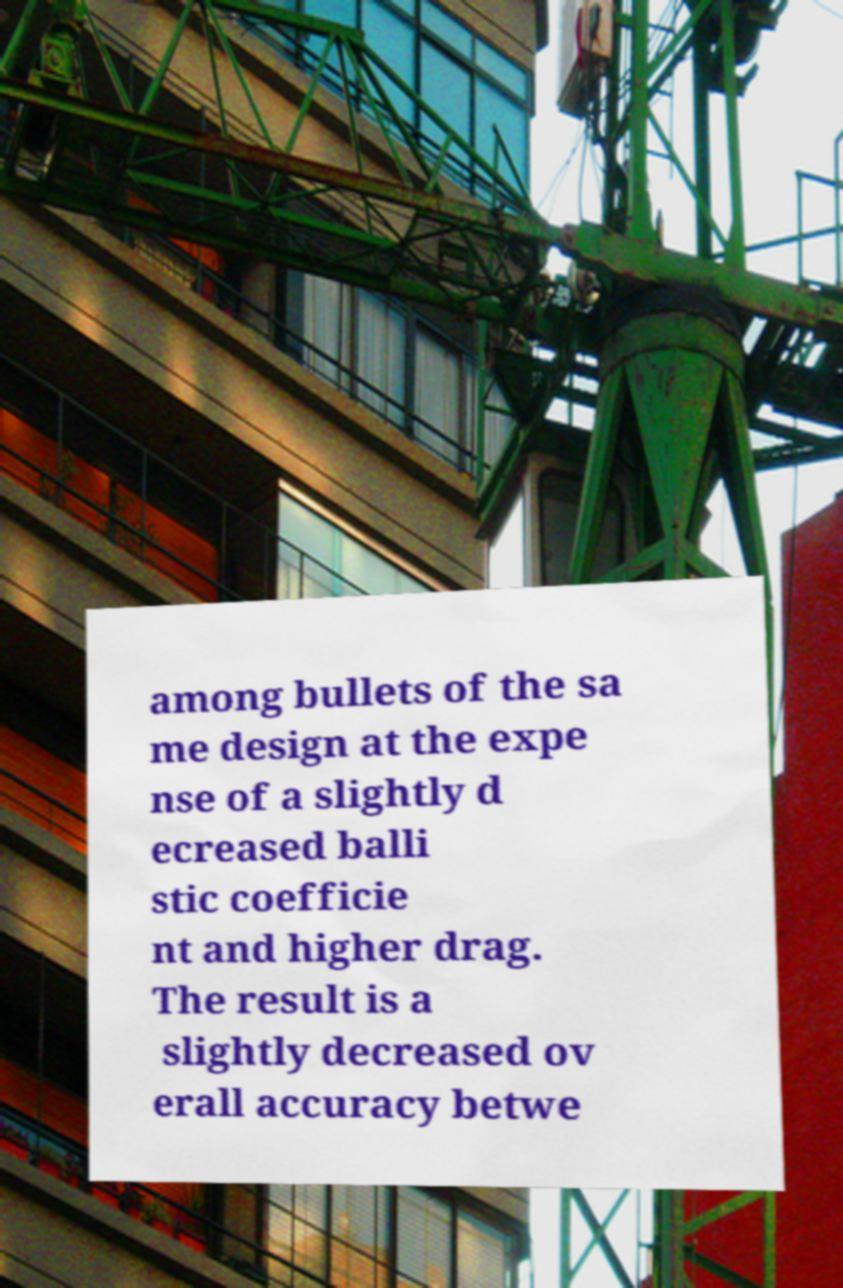What messages or text are displayed in this image? I need them in a readable, typed format. among bullets of the sa me design at the expe nse of a slightly d ecreased balli stic coefficie nt and higher drag. The result is a slightly decreased ov erall accuracy betwe 